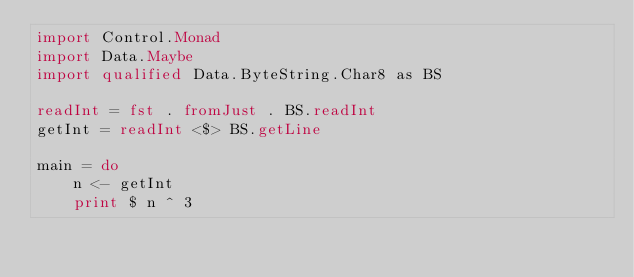Convert code to text. <code><loc_0><loc_0><loc_500><loc_500><_Haskell_>import Control.Monad
import Data.Maybe
import qualified Data.ByteString.Char8 as BS

readInt = fst . fromJust . BS.readInt
getInt = readInt <$> BS.getLine

main = do
    n <- getInt
    print $ n ^ 3</code> 